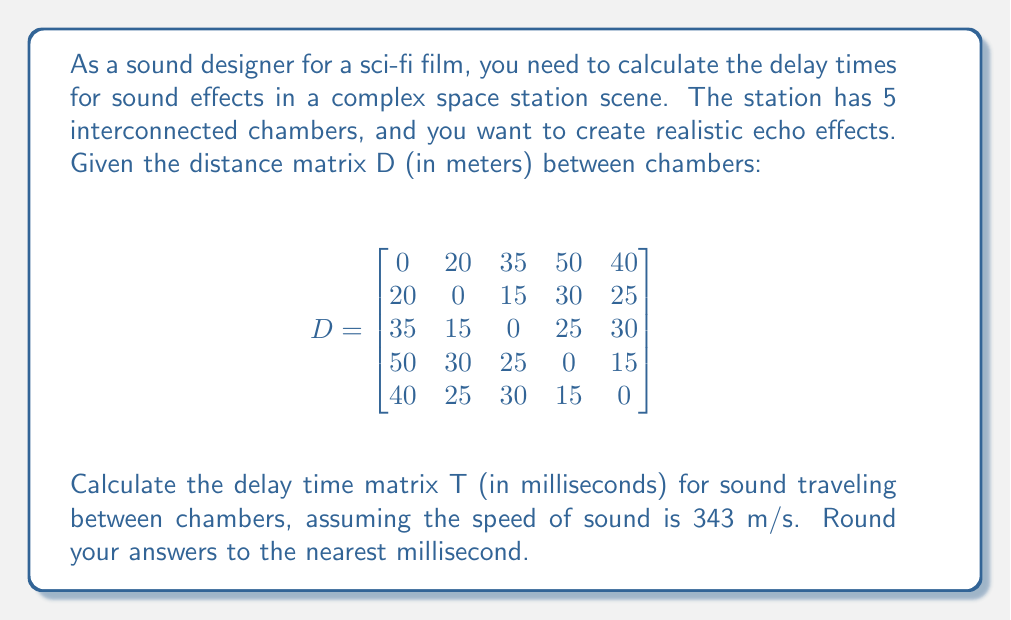Could you help me with this problem? To solve this problem, we need to follow these steps:

1) The formula for delay time is:
   $t = \frac{d}{v}$
   where t is time, d is distance, and v is velocity (speed of sound)

2) We need to divide each element in the distance matrix by the speed of sound (343 m/s) and multiply by 1000 to convert seconds to milliseconds:

   $T_{ij} = \frac{D_{ij}}{343} \times 1000$

3) Let's calculate this for each element:

   $T_{11} = \frac{0}{343} \times 1000 = 0$ ms
   $T_{12} = T_{21} = \frac{20}{343} \times 1000 \approx 58$ ms
   $T_{13} = T_{31} = \frac{35}{343} \times 1000 \approx 102$ ms
   $T_{14} = T_{41} = \frac{50}{343} \times 1000 \approx 146$ ms
   $T_{15} = T_{51} = \frac{40}{343} \times 1000 \approx 117$ ms
   $T_{23} = T_{32} = \frac{15}{343} \times 1000 \approx 44$ ms
   $T_{24} = T_{42} = \frac{30}{343} \times 1000 \approx 87$ ms
   $T_{25} = T_{52} = \frac{25}{343} \times 1000 \approx 73$ ms
   $T_{34} = T_{43} = \frac{25}{343} \times 1000 \approx 73$ ms
   $T_{35} = T_{53} = \frac{30}{343} \times 1000 \approx 87$ ms
   $T_{45} = T_{54} = \frac{15}{343} \times 1000 \approx 44$ ms

4) Arranging these values into a matrix:

$$T = \begin{bmatrix}
0 & 58 & 102 & 146 & 117 \\
58 & 0 & 44 & 87 & 73 \\
102 & 44 & 0 & 73 & 87 \\
146 & 87 & 73 & 0 & 44 \\
117 & 73 & 87 & 44 & 0
\end{bmatrix}$$
Answer: $$T = \begin{bmatrix}
0 & 58 & 102 & 146 & 117 \\
58 & 0 & 44 & 87 & 73 \\
102 & 44 & 0 & 73 & 87 \\
146 & 87 & 73 & 0 & 44 \\
117 & 73 & 87 & 44 & 0
\end{bmatrix}$$ ms 